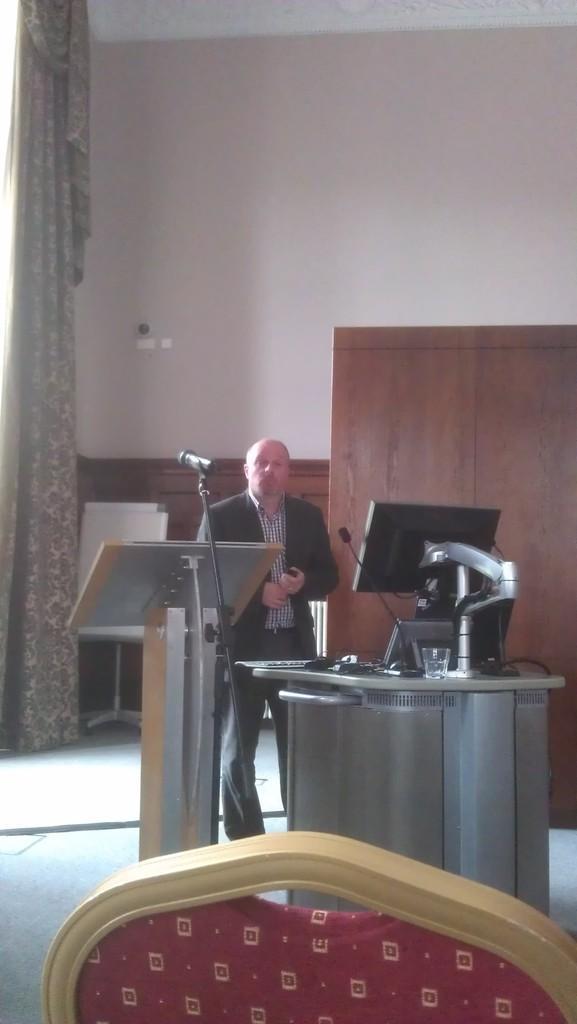In one or two sentences, can you explain what this image depicts? In this image there is a person standing, in front of him there is a table. On the table there is a monitor, glass, keyboard, mouse and some other objects placed, beside the table there is another table and mic. In the foreground of the image there is a chair. In the background there is a wooden structure, curtains and a wall. 